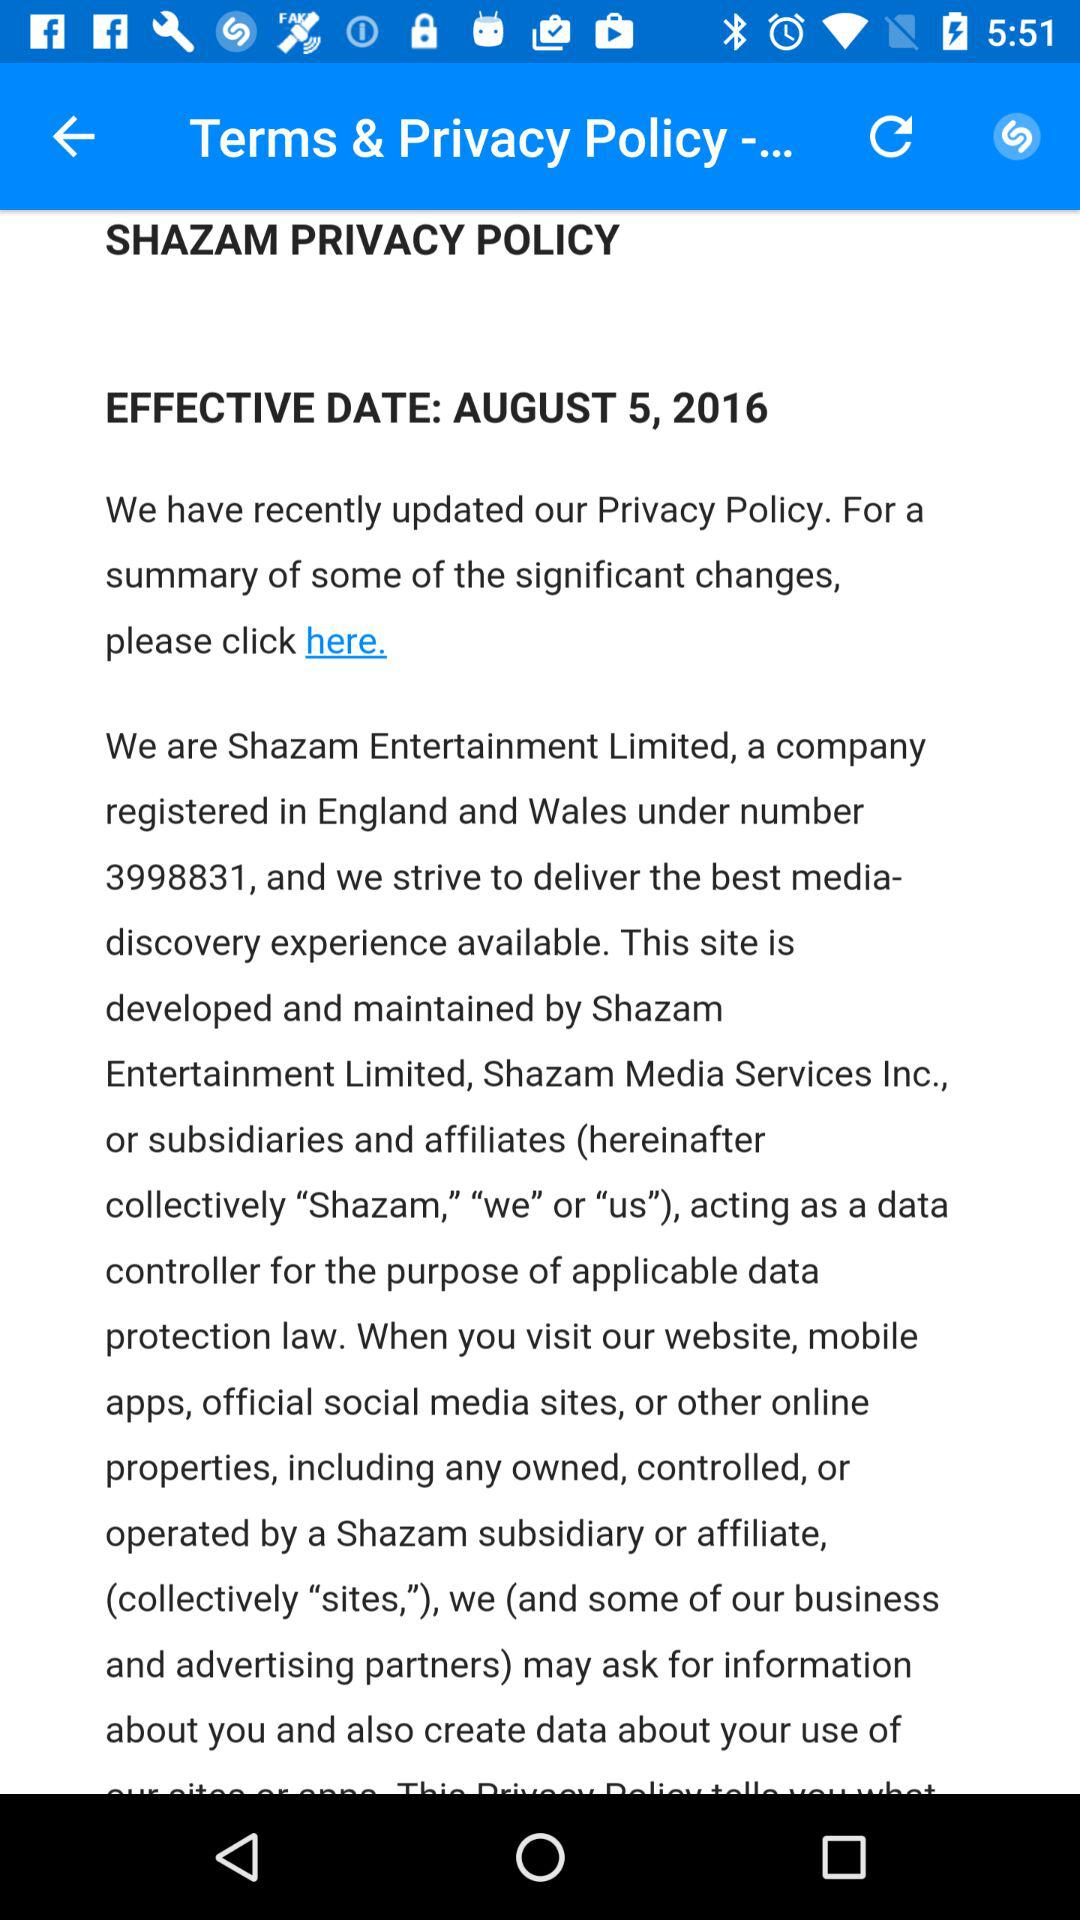What is the effective date? The effective date is August 5, 2016. 